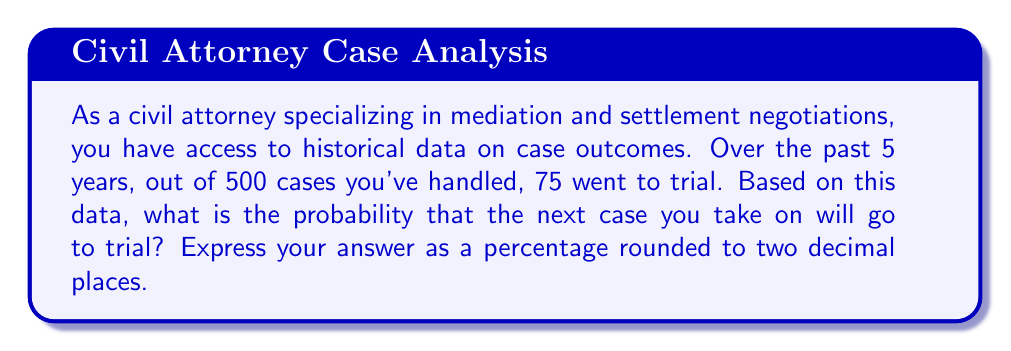Can you solve this math problem? To solve this problem, we'll use the concept of relative frequency as an estimate of probability. Here's the step-by-step solution:

1. Identify the total number of cases:
   $n = 500$

2. Identify the number of cases that went to trial:
   $k = 75$

3. Calculate the relative frequency:
   $$P(\text{case goes to trial}) = \frac{\text{number of cases that went to trial}}{\text{total number of cases}}$$
   $$P(\text{case goes to trial}) = \frac{k}{n} = \frac{75}{500}$$

4. Simplify the fraction:
   $$\frac{75}{500} = \frac{3}{20} = 0.15$$

5. Convert to a percentage:
   $$0.15 \times 100\% = 15\%$$

6. Round to two decimal places:
   $$15.00\%$$

Therefore, based on the historical data, there is a 15.00% chance that the next case you take on will go to trial.
Answer: 15.00% 